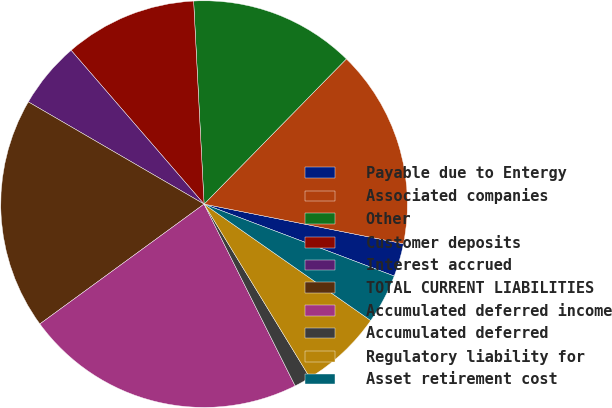Convert chart. <chart><loc_0><loc_0><loc_500><loc_500><pie_chart><fcel>Payable due to Entergy<fcel>Associated companies<fcel>Other<fcel>Customer deposits<fcel>Interest accrued<fcel>TOTAL CURRENT LIABILITIES<fcel>Accumulated deferred income<fcel>Accumulated deferred<fcel>Regulatory liability for<fcel>Asset retirement cost<nl><fcel>2.63%<fcel>15.79%<fcel>13.16%<fcel>10.53%<fcel>5.27%<fcel>18.42%<fcel>22.36%<fcel>1.32%<fcel>6.58%<fcel>3.95%<nl></chart> 